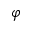<formula> <loc_0><loc_0><loc_500><loc_500>\varphi</formula> 